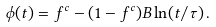<formula> <loc_0><loc_0><loc_500><loc_500>\phi ( t ) = f ^ { c } - ( 1 - f ^ { c } ) B \ln ( t / \tau ) \, .</formula> 